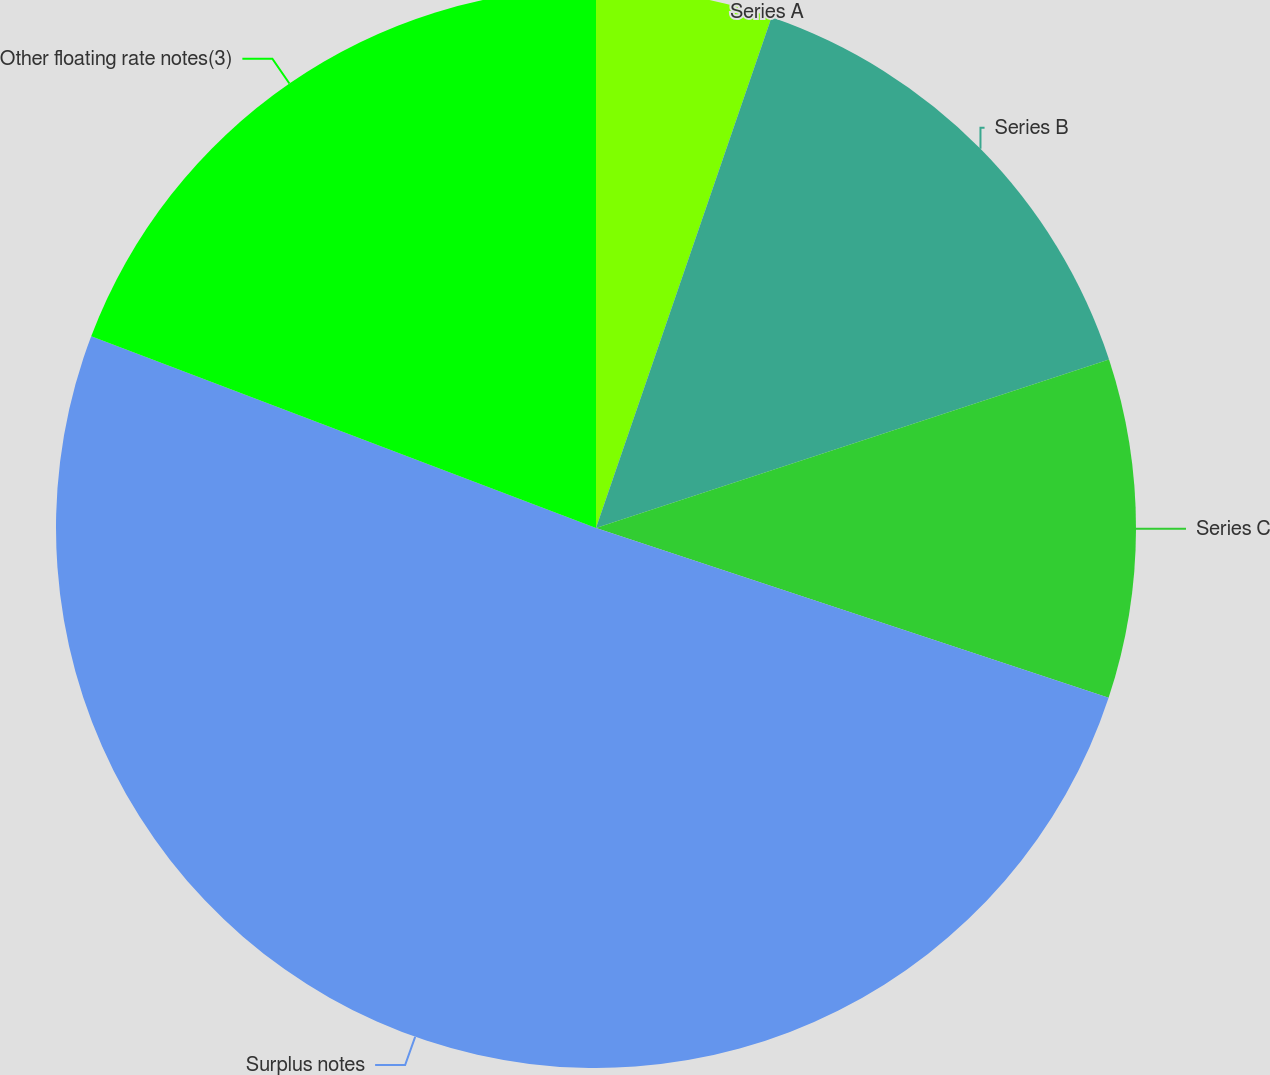<chart> <loc_0><loc_0><loc_500><loc_500><pie_chart><fcel>Series A<fcel>Series B<fcel>Series C<fcel>Surplus notes<fcel>Other floating rate notes(3)<nl><fcel>5.27%<fcel>14.68%<fcel>10.14%<fcel>50.69%<fcel>19.22%<nl></chart> 